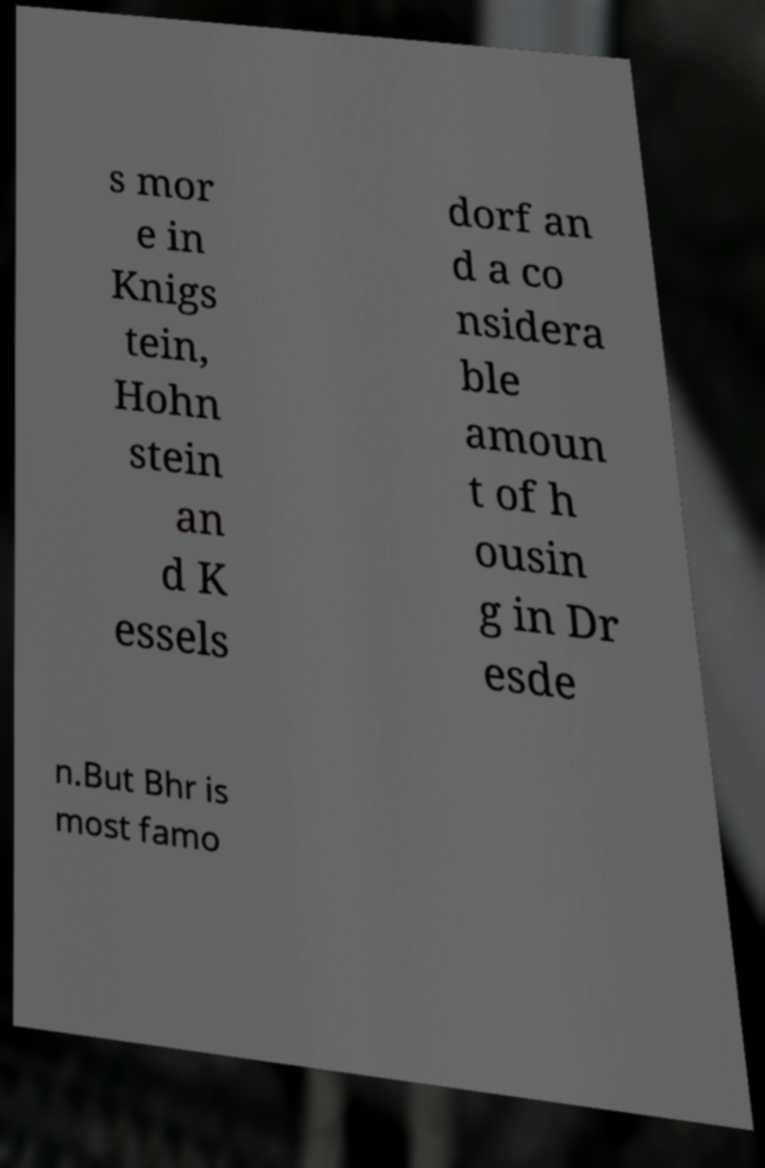Could you extract and type out the text from this image? s mor e in Knigs tein, Hohn stein an d K essels dorf an d a co nsidera ble amoun t of h ousin g in Dr esde n.But Bhr is most famo 